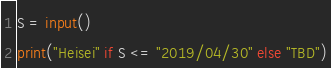<code> <loc_0><loc_0><loc_500><loc_500><_Python_>

S = input()
print("Heisei" if S <= "2019/04/30" else "TBD")
</code> 